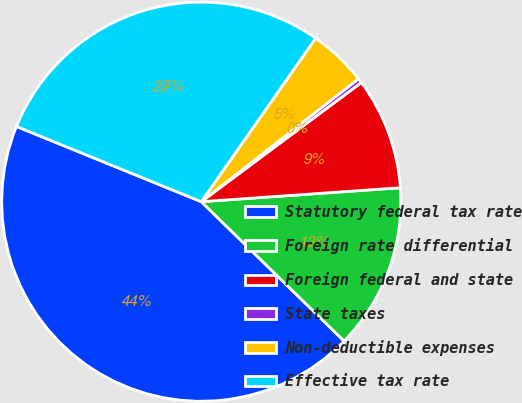<chart> <loc_0><loc_0><loc_500><loc_500><pie_chart><fcel>Statutory federal tax rate<fcel>Foreign rate differential<fcel>Foreign federal and state<fcel>State taxes<fcel>Non-deductible expenses<fcel>Effective tax rate<nl><fcel>43.85%<fcel>13.42%<fcel>9.07%<fcel>0.38%<fcel>4.72%<fcel>28.56%<nl></chart> 